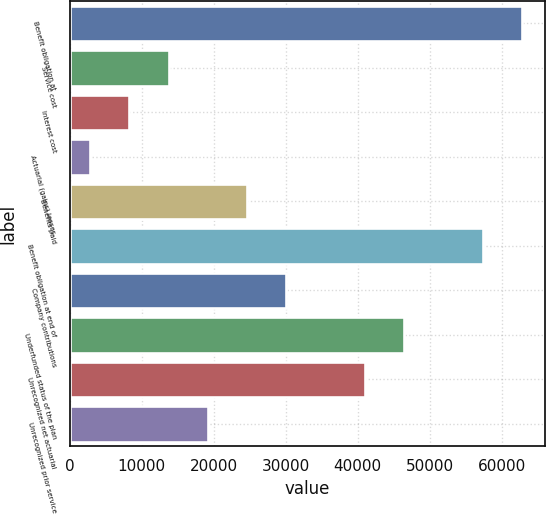Convert chart to OTSL. <chart><loc_0><loc_0><loc_500><loc_500><bar_chart><fcel>Benefit obligation at<fcel>Service cost<fcel>Interest cost<fcel>Actuarial (gains) losses<fcel>Benefits paid<fcel>Benefit obligation at end of<fcel>Company contributions<fcel>Underfunded status of the plan<fcel>Unrecognized net actuarial<fcel>Unrecognized prior service<nl><fcel>62822.4<fcel>13714.8<fcel>8258.4<fcel>2802<fcel>24627.6<fcel>57366<fcel>30084<fcel>46453.2<fcel>40996.8<fcel>19171.2<nl></chart> 